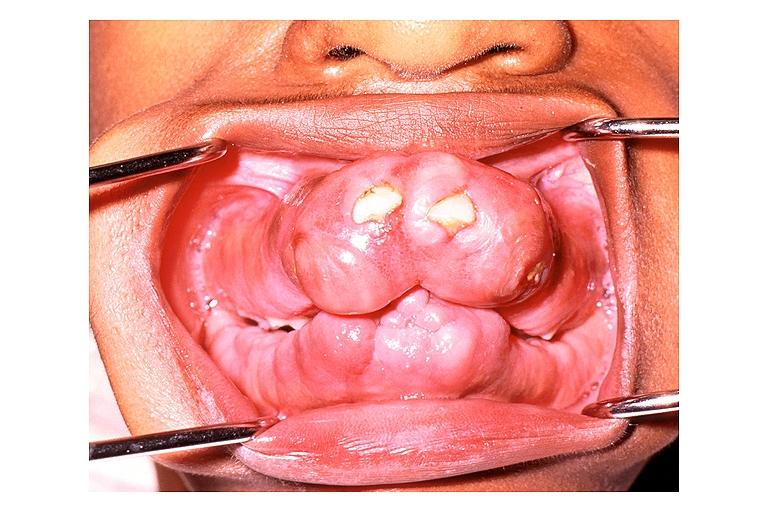where is this?
Answer the question using a single word or phrase. Oral 